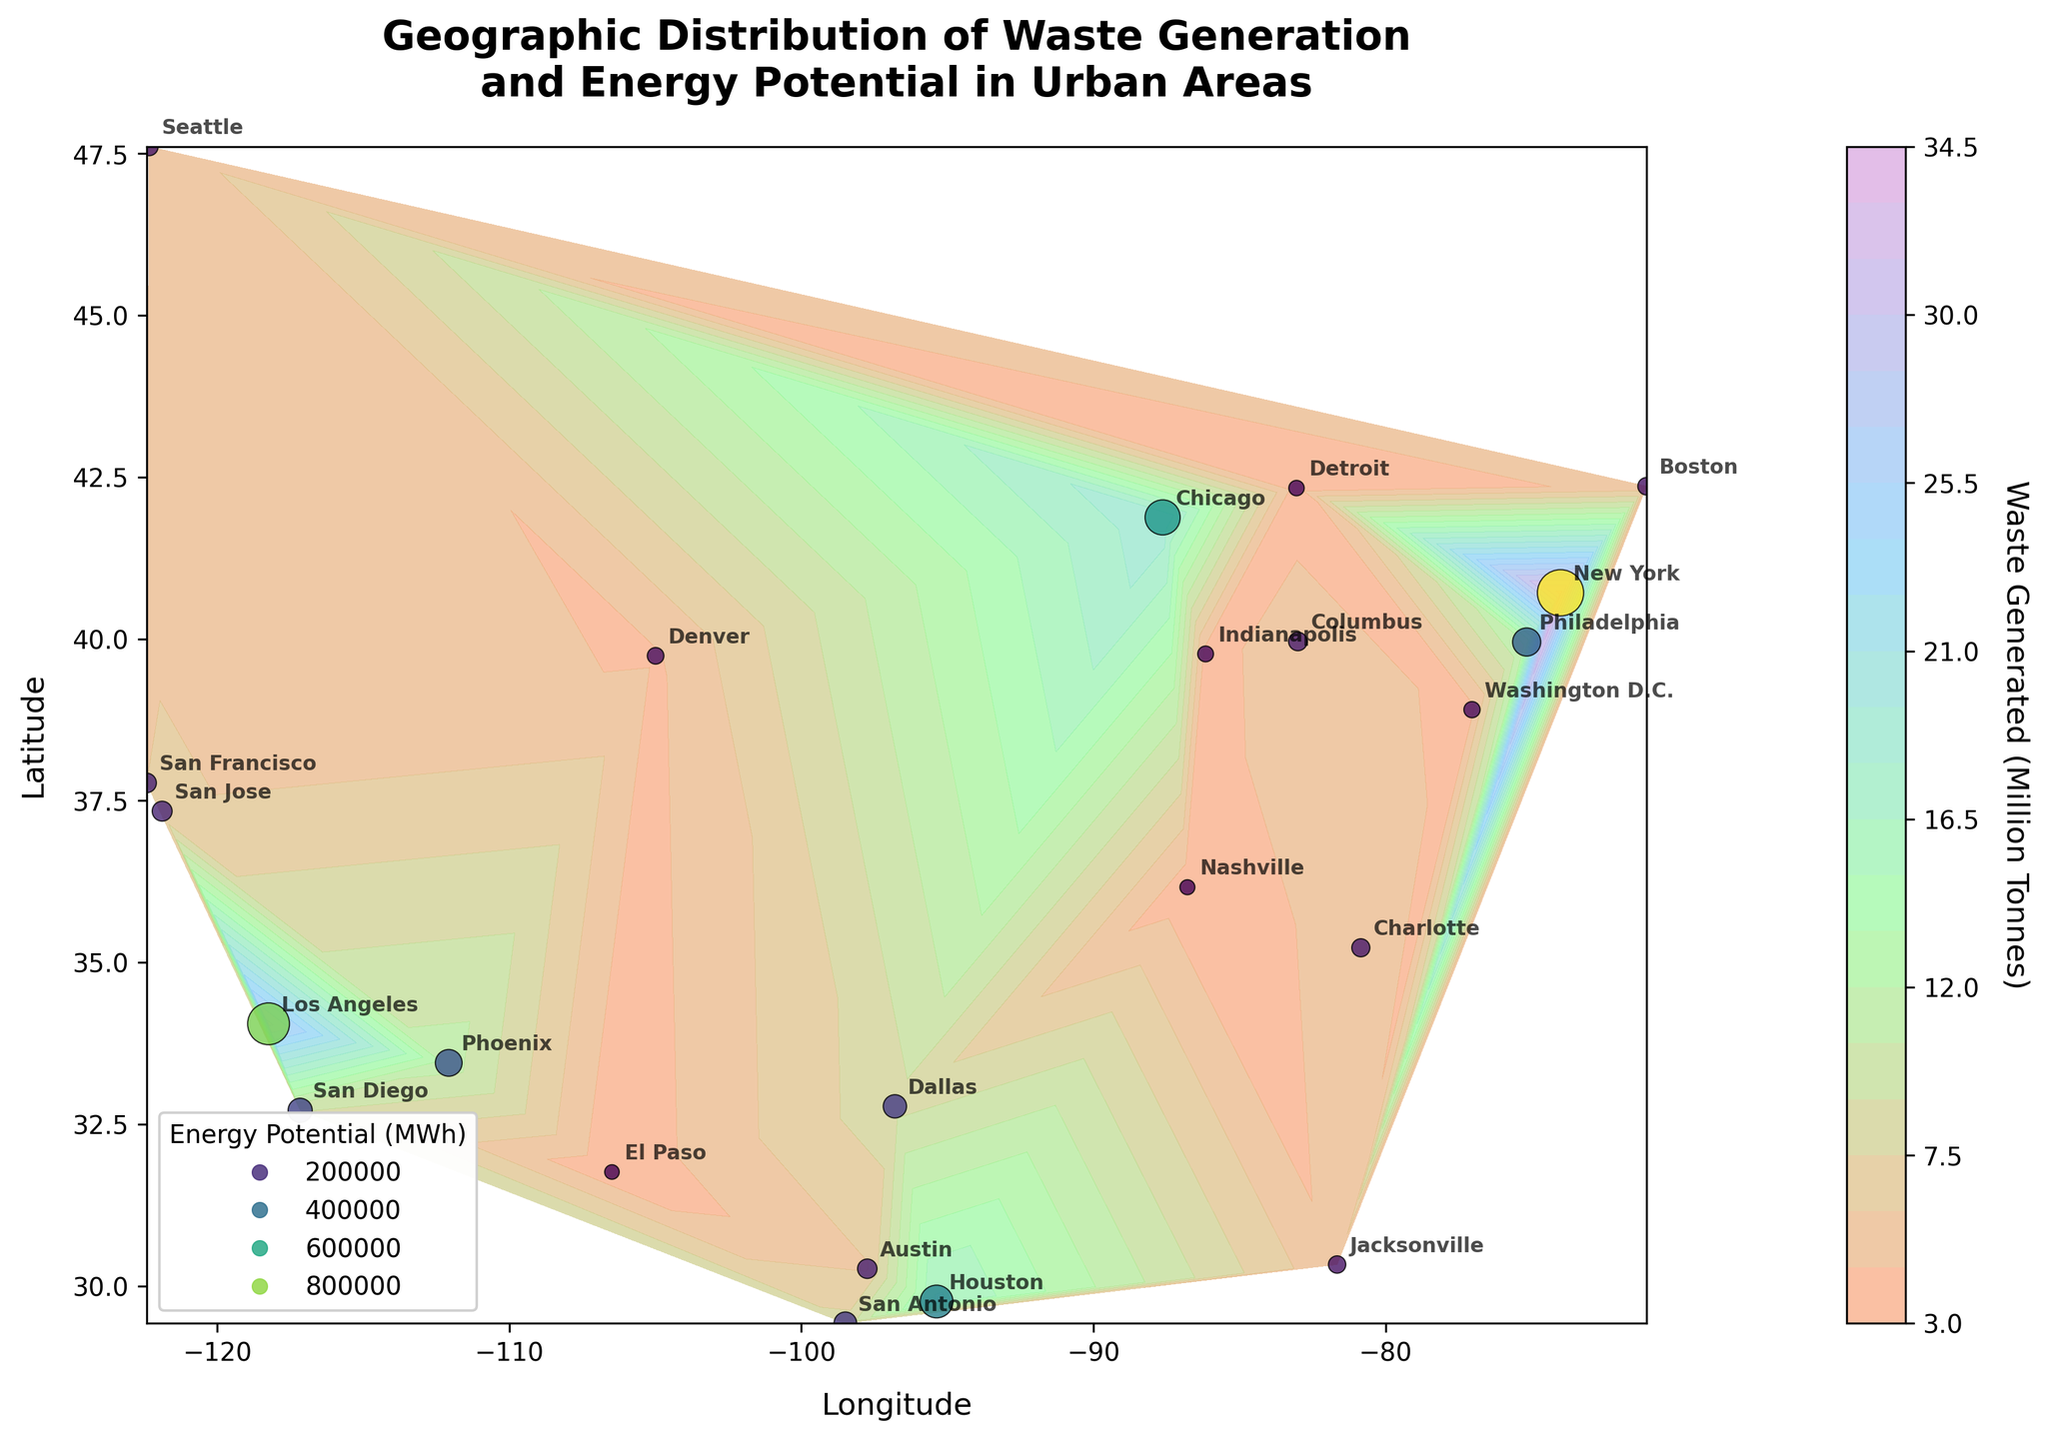What is the title of the contour plot? The title of a figure is usually located at the top and summarizes the main topic or objective of the plot. The title in this case helps us understand that the plot shows both waste generation and energy potential across various urban areas.
Answer: Geographic Distribution of Waste Generation and Energy Potential in Urban Areas Which city has the highest level of waste generated? To determine the city with the highest waste generated, look for the city label where the contour plot or scatter plot has the highest corresponding size or color in relation to waste generated. New York stands out visually.
Answer: New York How many cities are labeled on the contour plot? Counting the number of city labels displayed on the plot provides the answer. Each label represents one city.
Answer: 23 What are the axis labels in the contour plot? The axis labels provide information on what the X and Y axes represent. Look towards the sides of the plot for these labels. The X-axis typically shows longitude while the Y-axis shows latitude.
Answer: Longitude (X) and Latitude (Y) Which city has the lowest energy potential? Look for the city with the smallest scatter size or the least intense color in terms of energy potential. El Paso has the lowest value.
Answer: El Paso Compare the waste generated between Los Angeles and San Francisco. Which one is greater and by how much? Identify the waste generated values for both cities from the data points or scatter size. Los Angeles has 27.4 million tonnes, and San Francisco has 6.0 million tonnes. Subtract the value for San Francisco from Los Angeles to get the difference.
Answer: Los Angeles is greater by 21.4 million tonnes Are there more cities with waste generation above 10 million tonnes or below? Count the number of city labels where the waste generation value exceeds 10 million tonnes and compare it to those below 10 million tonnes. There are more cities below 10 million tonnes.
Answer: Below 10 million tonnes What is the trend in energy potential with respect to waste generated? Examine the scatter plot and contour plot to see if there is a visible trend. Higher values of waste generated tend to correspond with higher energy potential, indicating a positive correlation.
Answer: Positive correlation Which city has the highest latitude among the cities plotted? Find the city located furthest to the top in the plot as latitude increases upwards. Seattle is at the highest latitude.
Answer: Seattle Is there any city located at both high waste generation and high energy potential regions? Look for cities that appear in the intense regions of both the contour plot and scatter plot. New York and Los Angeles are prominent in both plots, indicating high values for both metrics.
Answer: New York and Los Angeles 